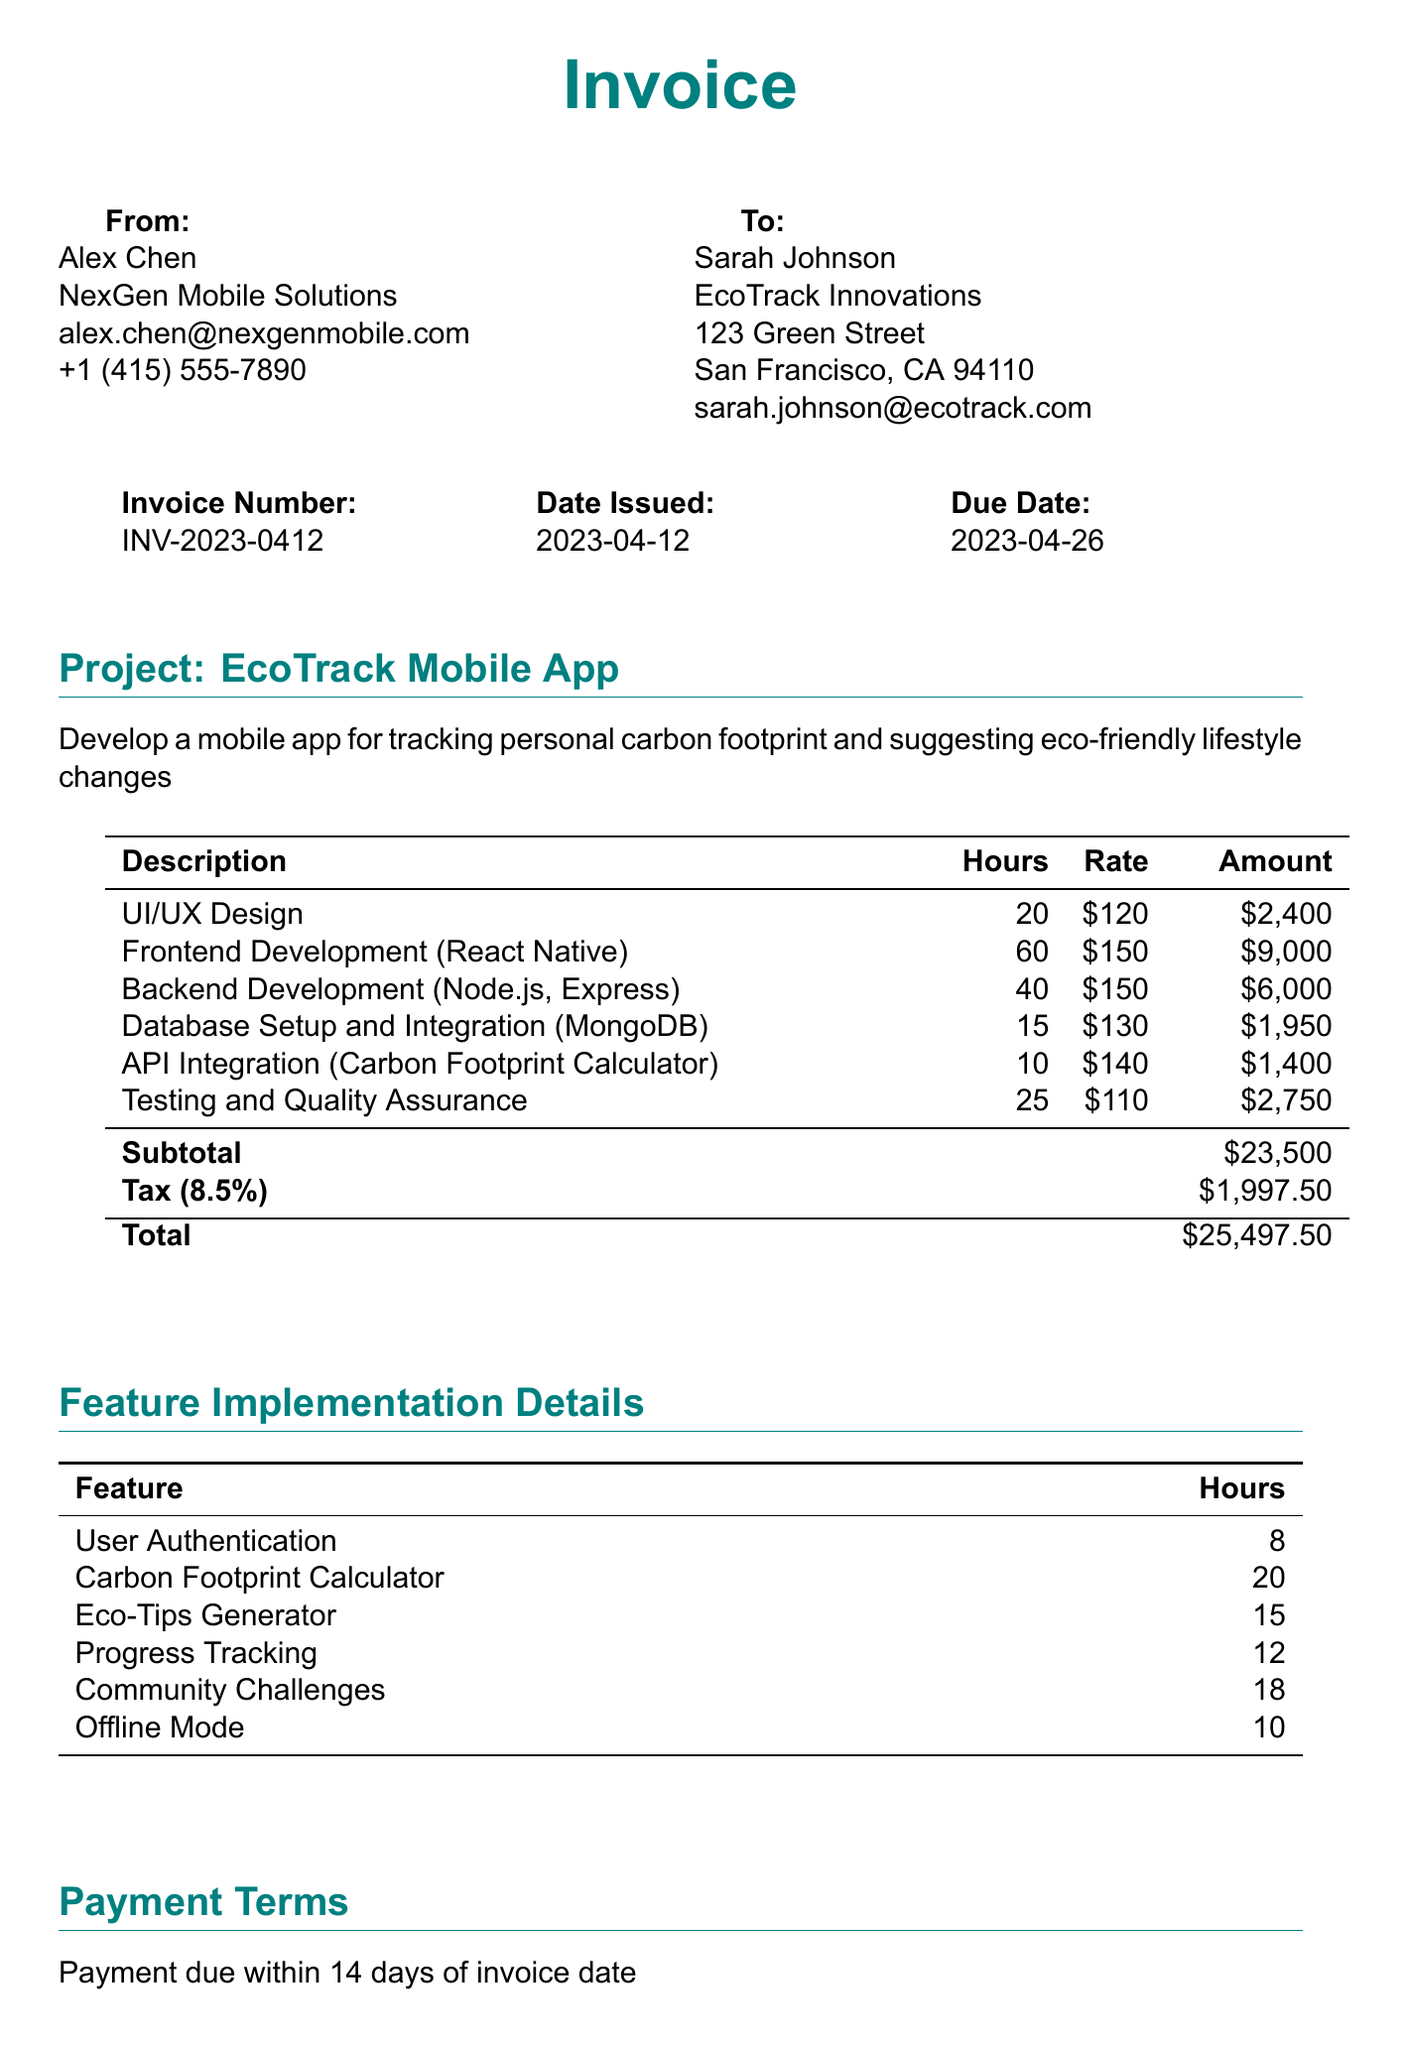What is the invoice number? The invoice number is listed clearly at the top of the document as a unique identifier.
Answer: INV-2023-0412 Who is the developer? The developer's name and contact details are provided, indicating who performed the services.
Answer: Alex Chen What is the total amount due? The total amount due is summarized at the bottom, reflecting all services rendered and applicable taxes.
Answer: $25,497.50 How many hours were spent on Frontend Development? The hours worked for each task are detailed in the line items section of the document.
Answer: 60 Which feature took the most hours to implement? The feature implementation details section lists features along with the respective hours, requiring comparison to find the maximum.
Answer: Carbon Footprint Calculator What is the payment term? Payment terms are typically outlined towards the end of the invoice to inform the client of the due timeframe.
Answer: Payment due within 14 days of invoice date What email can payments be sent to via PayPal? The payment methods section provides the details necessary for making payments through different channels.
Answer: payments@nexgenmobile.com What is the tax rate applied to the invoice? The tax rate should be specified in the invoice, indicating how taxes have been calculated on the subtotal.
Answer: 8.5% What is the subtotal amount before tax? The subtotal is a key figure on the invoice summarizing the total of all services before tax is added.
Answer: $23,500 